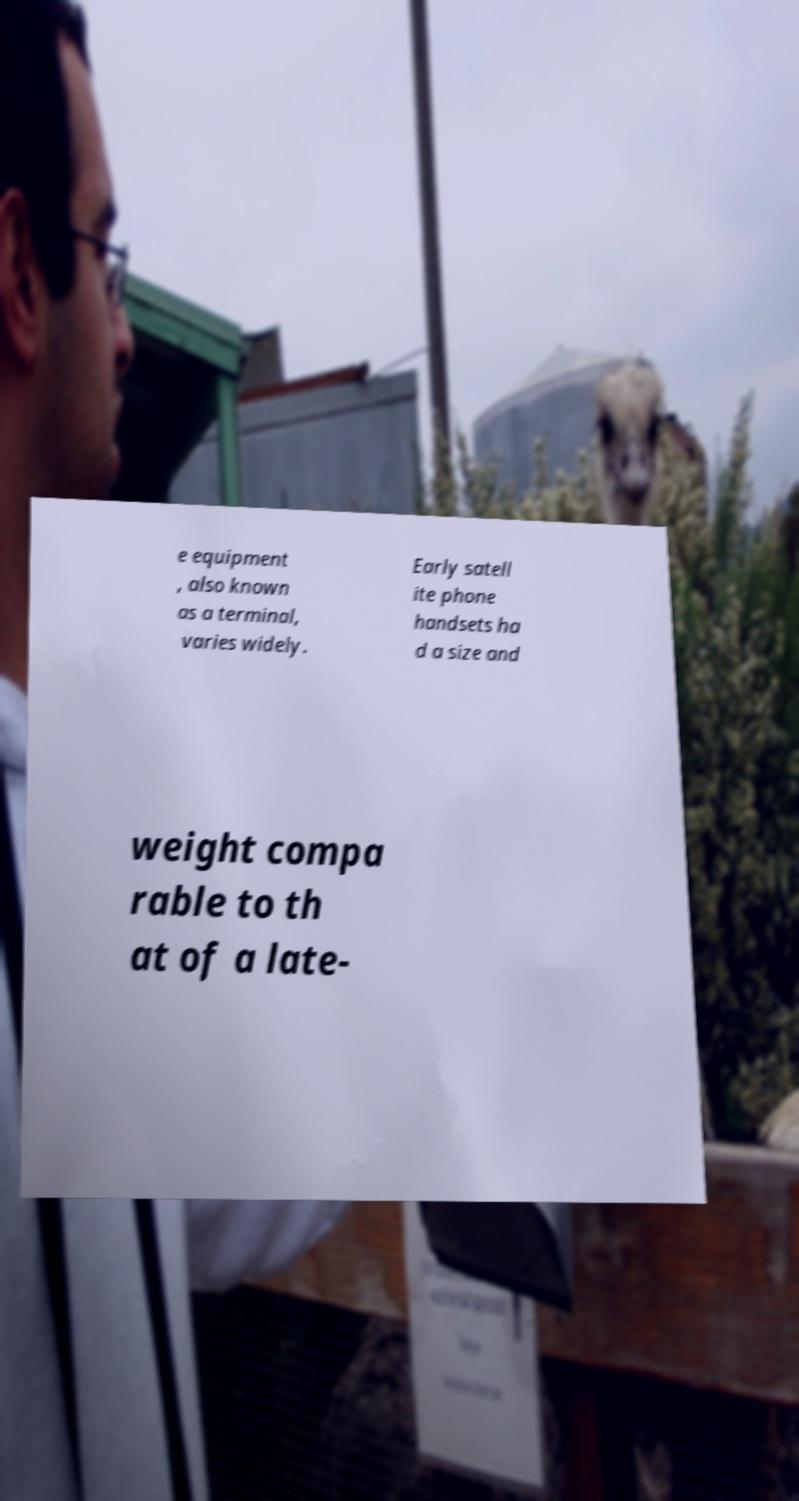Please read and relay the text visible in this image. What does it say? e equipment , also known as a terminal, varies widely. Early satell ite phone handsets ha d a size and weight compa rable to th at of a late- 